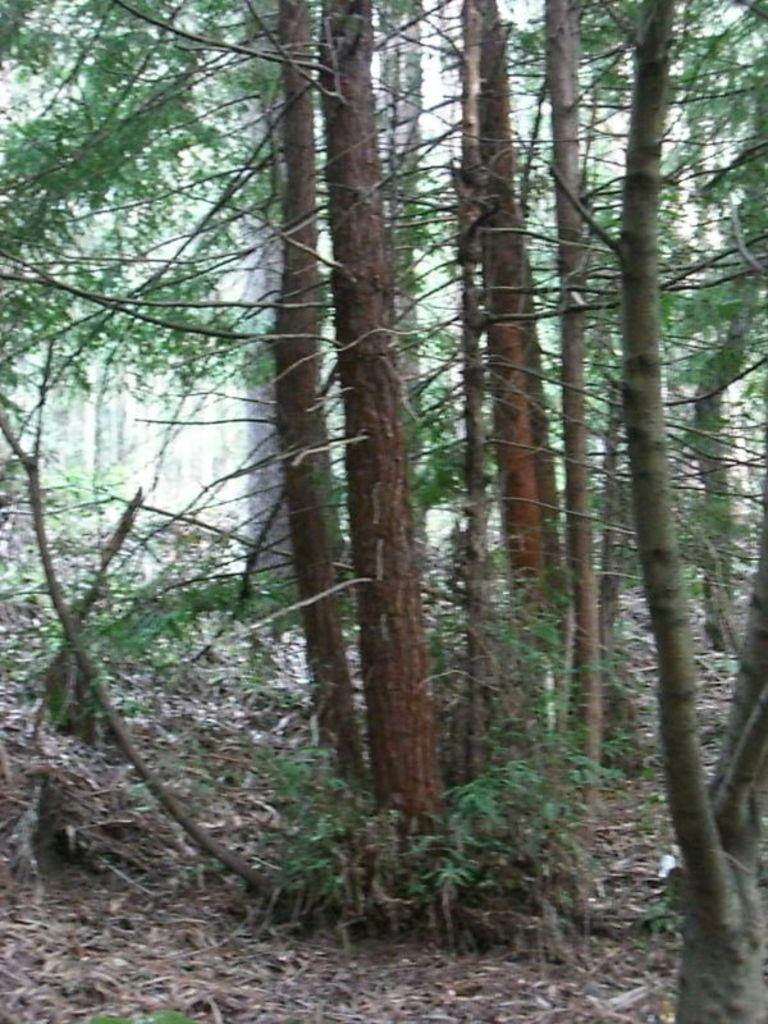What type of vegetation can be seen in the image? There are trees in the image. What can be found at the bottom of the image? There are dried leaves at the bottom of the image. What scent can be detected from the trees in the image? There is no information about the scent of the trees in the image, so it cannot be determined. 